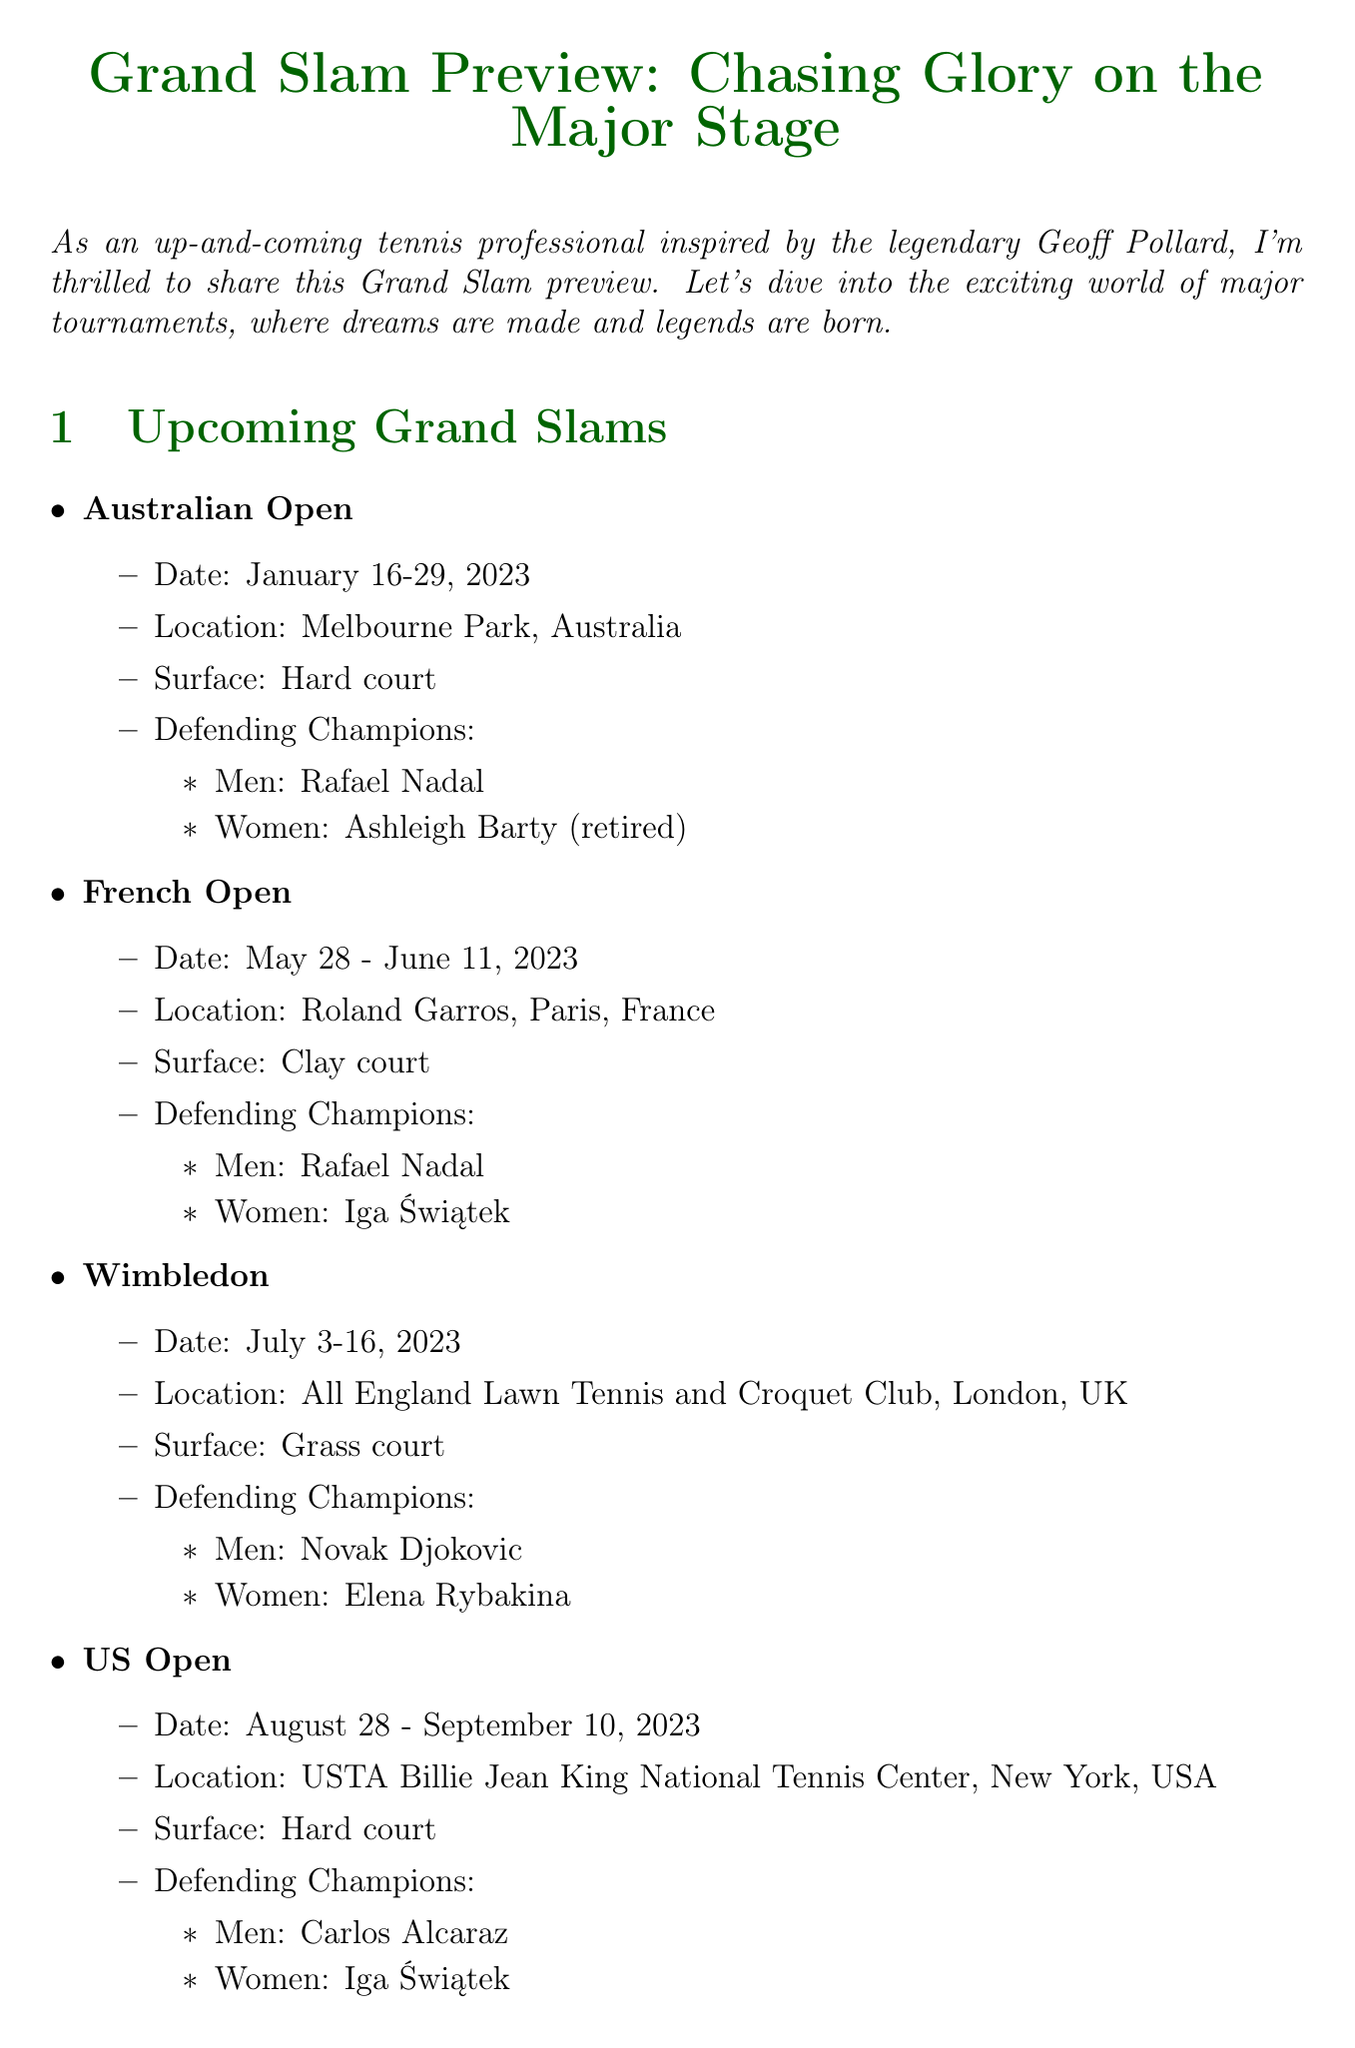What are the dates for the Australian Open? The document lists the dates for the Australian Open as January 16-29, 2023.
Answer: January 16-29, 2023 Who is the defending champion for the men's singles at Wimbledon? The document states that Novak Djokovic is the defending champion for the men's singles at Wimbledon.
Answer: Novak Djokovic What surface is used at the French Open? The French Open is played on clay court, as mentioned in the document.
Answer: Clay court Which player is predicted to win at least two Grand Slams this year? Martina Navratilova predicts that Iga Świątek will win at least two Grand Slams this year.
Answer: Iga Świątek What is Rafael Nadal's total Grand Slam titles mentioned in expert predictions? The expert predictions indicate a comparison with Rafael Nadal's record of 22 Grand Slam titles, but no direct count is given in the document.
Answer: 22 Who is ranked second in the women's player rankings? The document states that Aryna Sabalenka is ranked second in the women's player rankings.
Answer: Aryna Sabalenka What is the location of the US Open? According to the document, the US Open is located at USTA Billie Jean King National Tennis Center, New York, USA.
Answer: USTA Billie Jean King National Tennis Center, New York, USA What is the main theme of the newsletter? The main theme of the newsletter is about the Grand Slam preview and major tournaments.
Answer: Grand Slam preview How long did Geoff Pollard serve as President of Tennis Australia? The document indicates that Geoff Pollard served as President of Tennis Australia for 21 years (1989-2010).
Answer: 21 years 